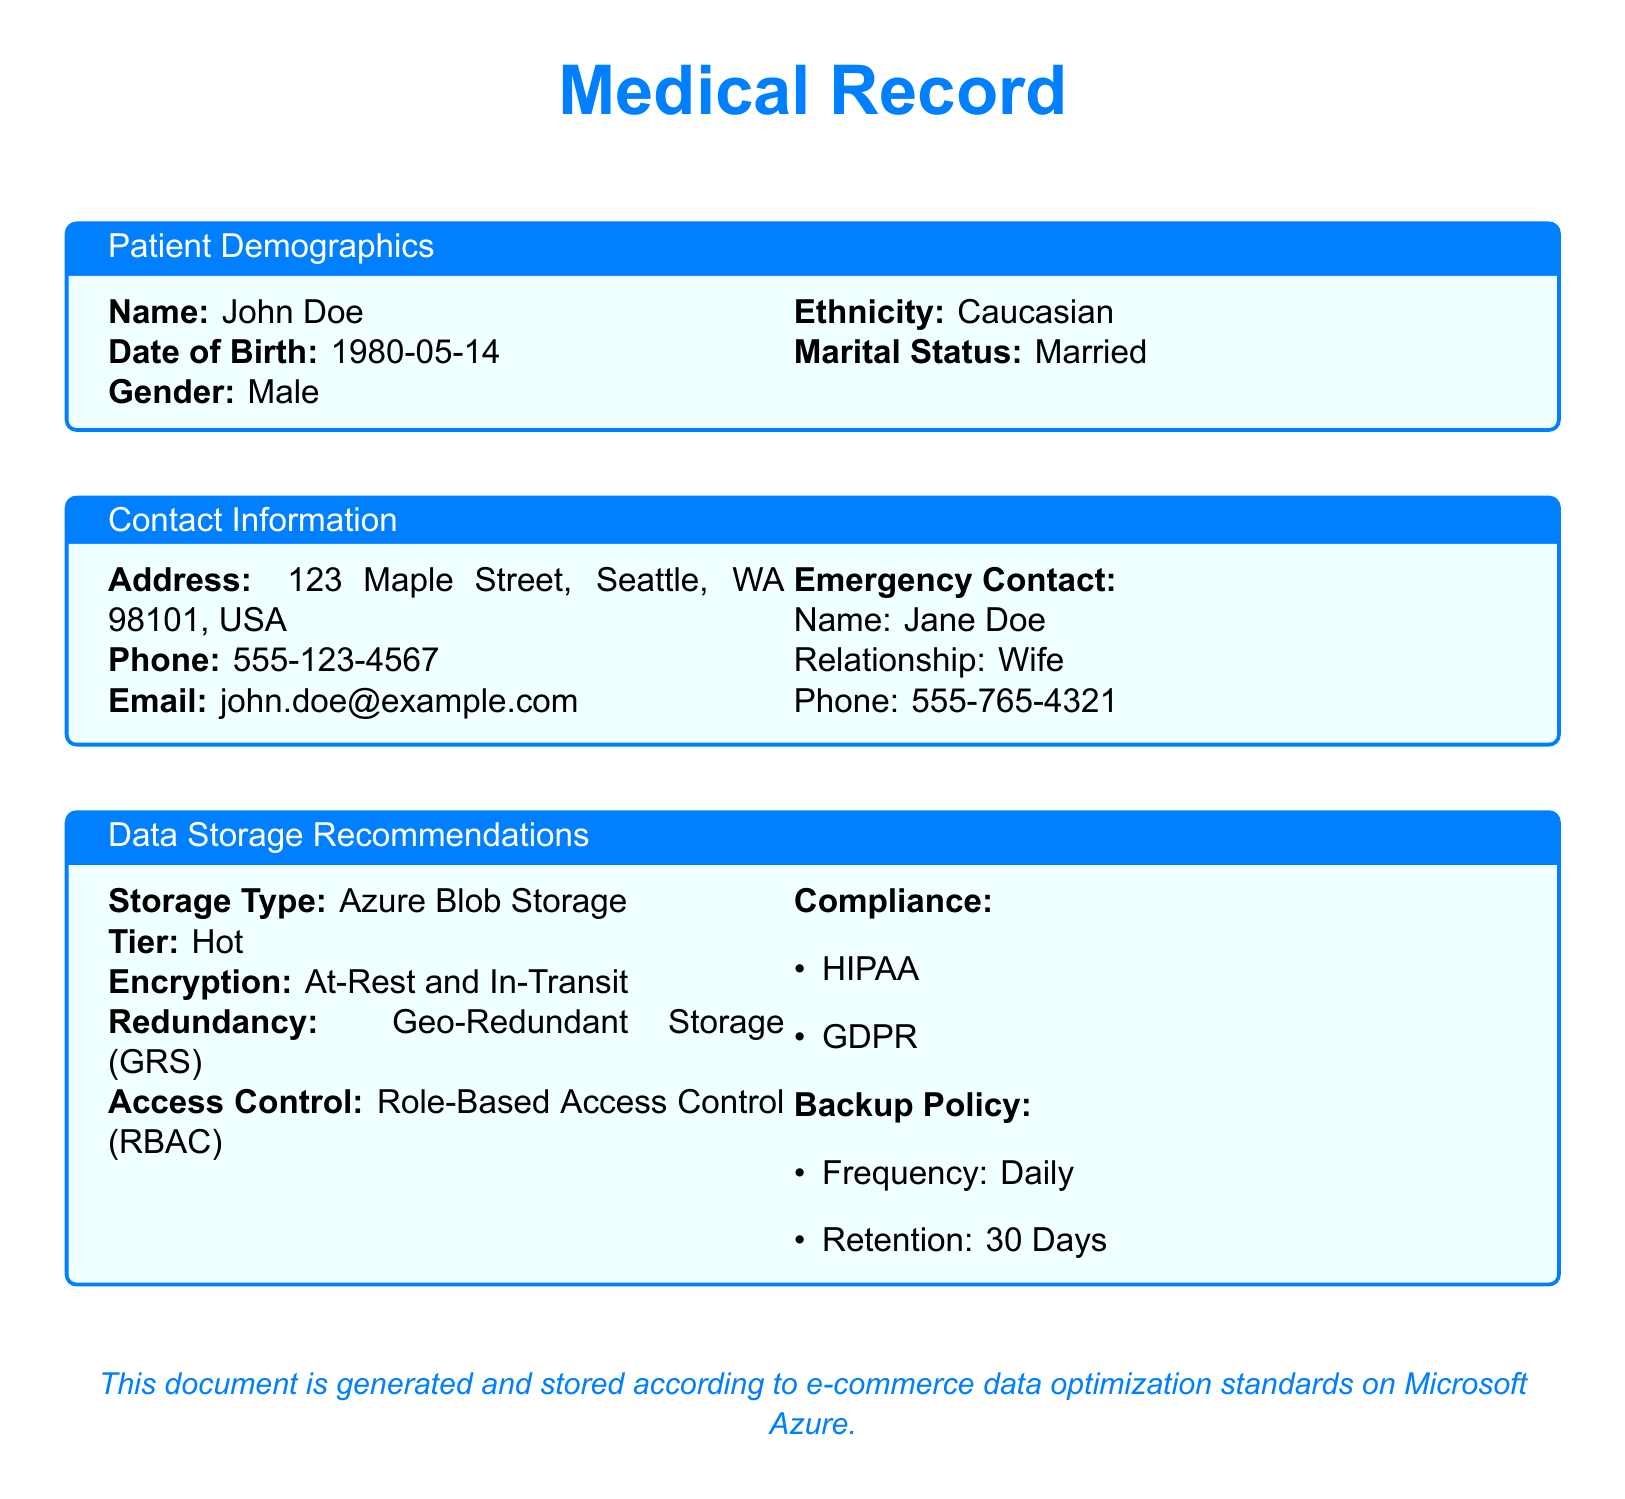What is the patient's name? The patient's name is specified in the document's demographics section.
Answer: John Doe What is the patient's date of birth? The date of birth for the patient is provided in the demographics section.
Answer: 1980-05-14 What is the patient's gender? The gender of the patient can be found in the demographics section of the document.
Answer: Male What is the patient's email address? The email address is listed in the contact information section.
Answer: john.doe@example.com What type of storage is recommended? The type of storage recommended for data is specified in the data storage recommendations section.
Answer: Azure Blob Storage How long is the backup retention policy? The retention policy for backups is mentioned in the data storage recommendations section.
Answer: 30 Days What compliance regulations are mentioned? The document lists compliance regulations in the data storage recommendations section.
Answer: HIPAA, GDPR Who is the patient's emergency contact? The emergency contact is detailed along with the relationship in the document.
Answer: Jane Doe What is the redundancy type for storage? The redundancy type for storage is outlined in the data storage recommendations.
Answer: Geo-Redundant Storage (GRS) 